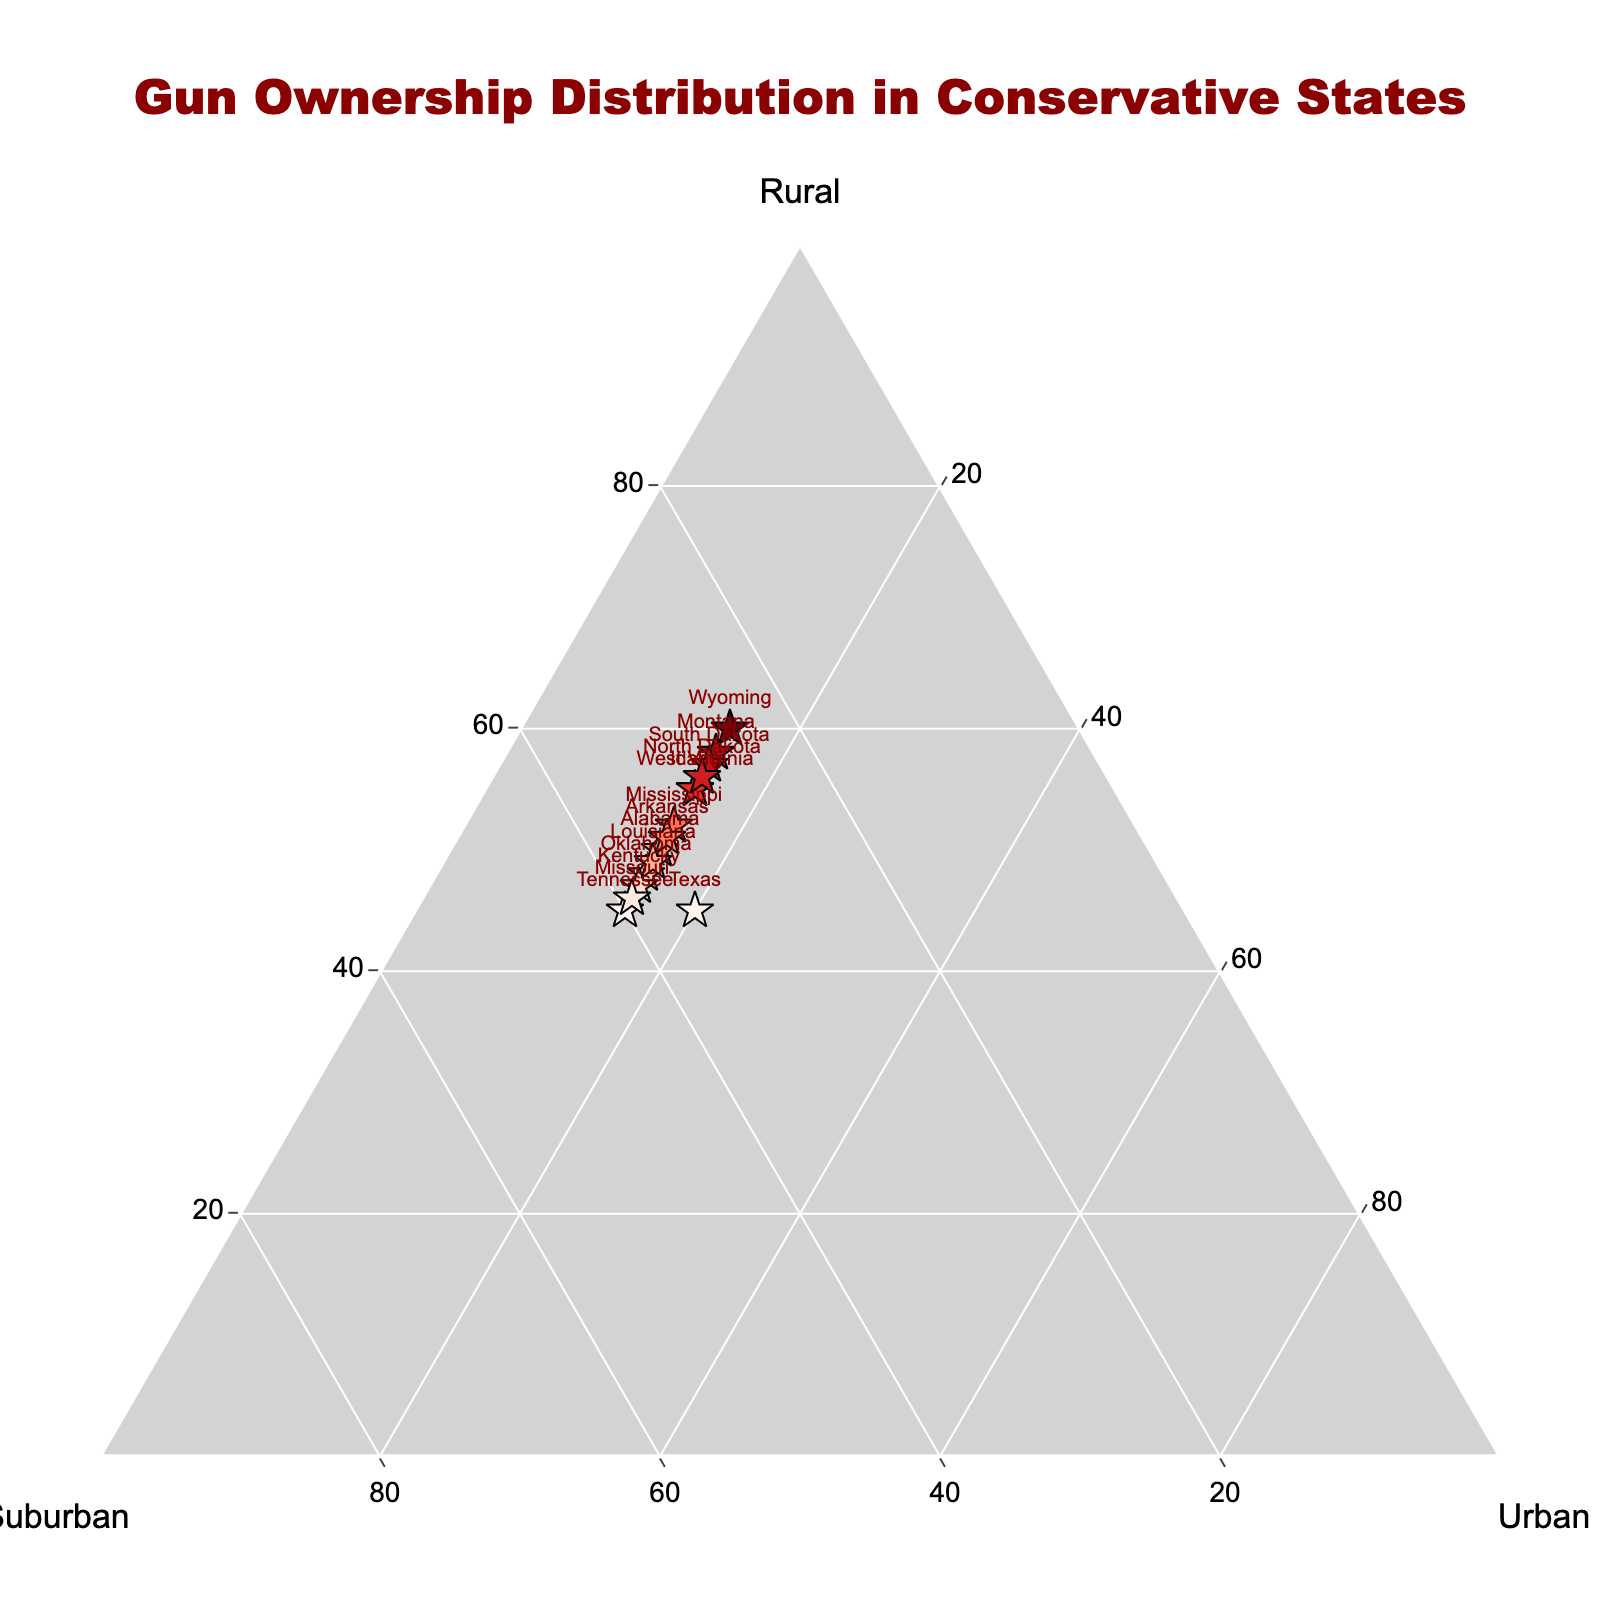How many states are represented in the plot? The plot includes individual markers for each state listed in the data. By counting these markers, we can determine the number of states represented.
Answer: 15 What is the title of the figure? The title can be seen at the top of the figure.
Answer: Gun Ownership Distribution in Conservative States Which state has the highest percentage of rural gun ownership? Check the markers in the plot for the one with the highest 'a' value, which corresponds to the Rural axis. Wyoming stands out as the state with 60% rural gun ownership.
Answer: Wyoming Which state has the smallest percentage of urban gun ownership? Look for the markers with the lowest value on the Urban (c) axis. Multiple states have the same lowest value of 15% for urban gun ownership, so any of them would be correct. Examples include Idaho and Alabama.
Answer: Idaho or Alabama What is the average rural gun ownership percentage across all states? To find the average, sum up the rural percentages and divide by the number of states: (45 + 55 + 50 + 60 + 58 + 48 + 52 + 55 + 47 + 51 + 45 + 57 + 56 + 46 + 49) / 15 = 49.86.
Answer: 49.86 Compare rural vs. suburban gun ownership in Texas. Which is higher? By looking at the marker for Texas, we see the values for Rural and Suburban are 45% and 35%, respectively.
Answer: Rural Is there any state with equal percentages of suburban and urban gun ownership? Check the data points where the values for Suburban (b) and Urban (c) are the same; no such state exists in the given data.
Answer: No Which states have exactly 15% urban gun ownership? Identify states where the Urban (c) axis value is 15%. The relevant states are Idaho, Alabama, Wyoming, Montana, Oklahoma, Mississippi, West Virginia, Kentucky, Arkansas, Tennessee, South Dakota, North Dakota, and Louisiana.
Answer: 13 states Which state shows the most balanced distribution between rural, suburban, and urban areas? Look for the state whose marker is closest to the center of the ternary plot where rural (a), suburban (b), and urban (c) values are nearly equal. Tennessee, with 45% Rural, 40% Suburban, and 15% Urban, is closest to balanced compared to others.
Answer: Tennessee 